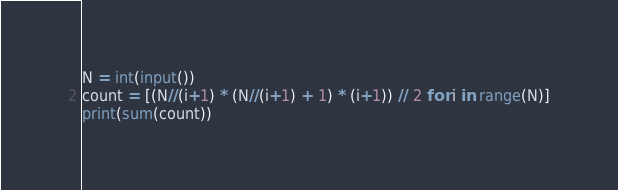<code> <loc_0><loc_0><loc_500><loc_500><_Python_>N = int(input())
count = [(N//(i+1) * (N//(i+1) + 1) * (i+1)) // 2 for i in range(N)]
print(sum(count))</code> 